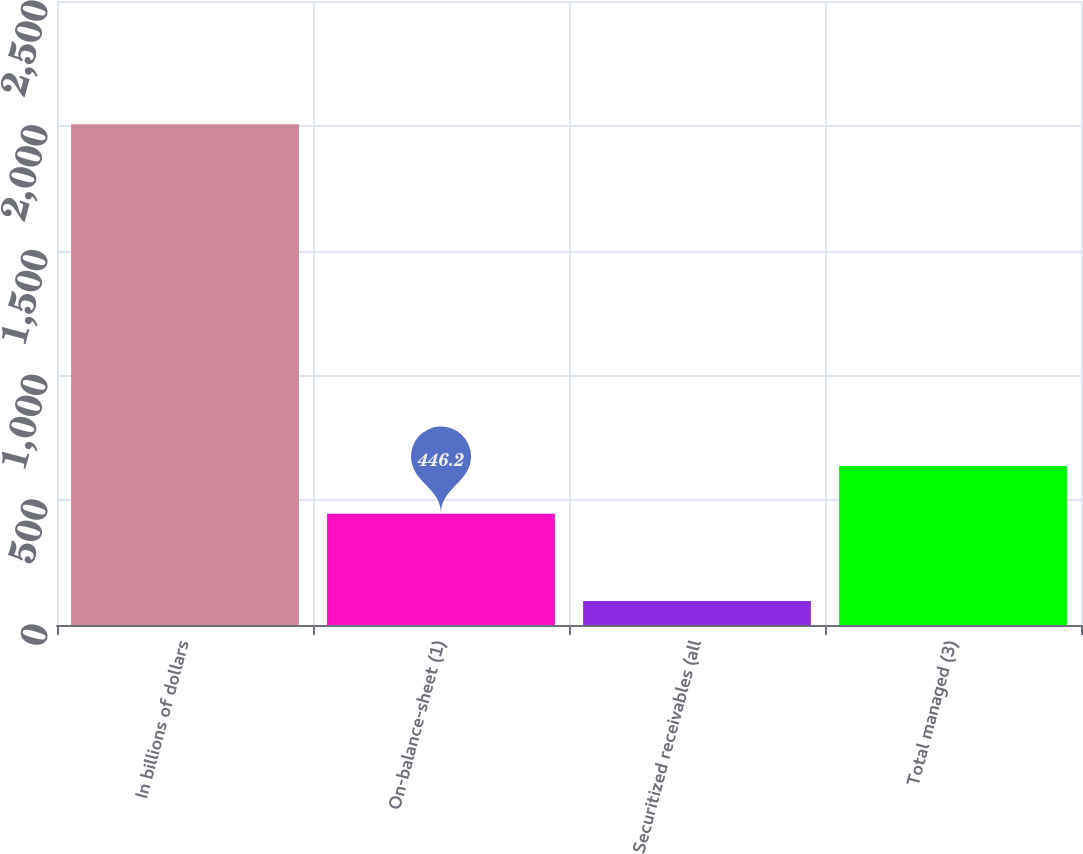<chart> <loc_0><loc_0><loc_500><loc_500><bar_chart><fcel>In billions of dollars<fcel>On-balance-sheet (1)<fcel>Securitized receivables (all<fcel>Total managed (3)<nl><fcel>2006<fcel>446.2<fcel>96.4<fcel>637.16<nl></chart> 